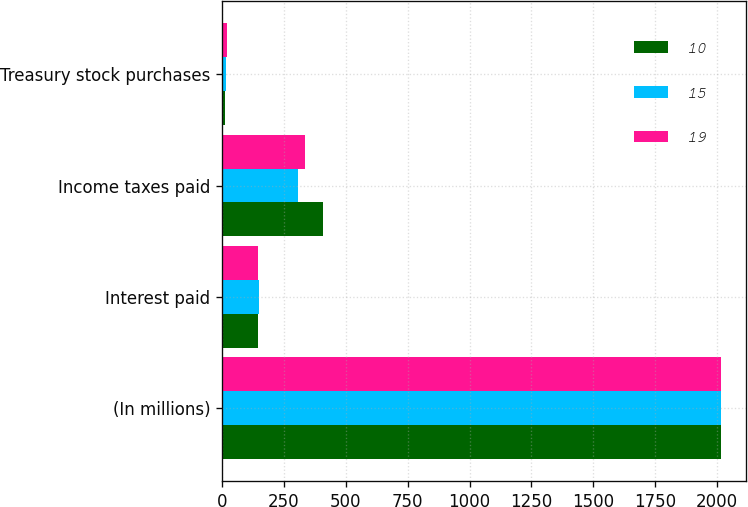<chart> <loc_0><loc_0><loc_500><loc_500><stacked_bar_chart><ecel><fcel>(In millions)<fcel>Interest paid<fcel>Income taxes paid<fcel>Treasury stock purchases<nl><fcel>10<fcel>2016<fcel>147<fcel>408<fcel>10<nl><fcel>15<fcel>2015<fcel>150<fcel>306<fcel>15<nl><fcel>19<fcel>2014<fcel>144<fcel>336<fcel>19<nl></chart> 